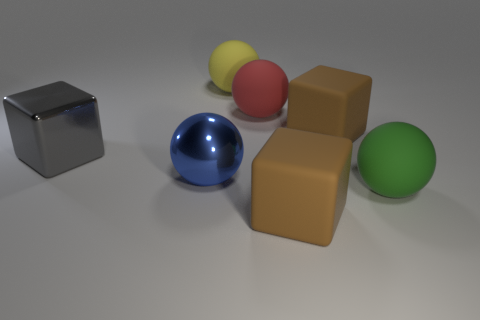What size is the block to the left of the matte object on the left side of the big red matte ball?
Offer a terse response. Large. What color is the other large metal object that is the same shape as the green object?
Give a very brief answer. Blue. How big is the shiny cube?
Give a very brief answer. Large. What number of cubes are either blue objects or big brown matte objects?
Offer a terse response. 2. There is a green rubber thing that is the same shape as the blue object; what is its size?
Provide a succinct answer. Large. What number of big brown matte things are there?
Offer a terse response. 2. There is a yellow object; is its shape the same as the large brown rubber thing that is behind the gray metallic block?
Your answer should be very brief. No. There is a brown rubber object that is behind the metal cube; what size is it?
Ensure brevity in your answer.  Large. What material is the yellow thing?
Keep it short and to the point. Rubber. Do the shiny object that is left of the blue thing and the yellow object have the same shape?
Offer a terse response. No. 